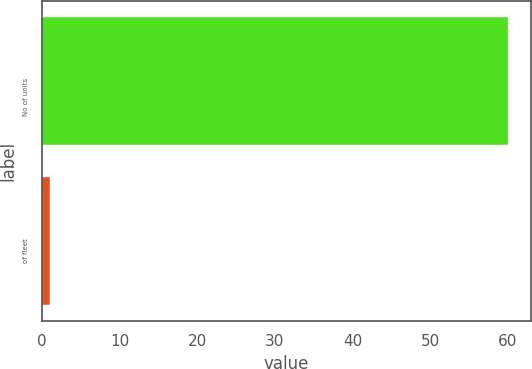Convert chart. <chart><loc_0><loc_0><loc_500><loc_500><bar_chart><fcel>No of units<fcel>of fleet<nl><fcel>60<fcel>1<nl></chart> 